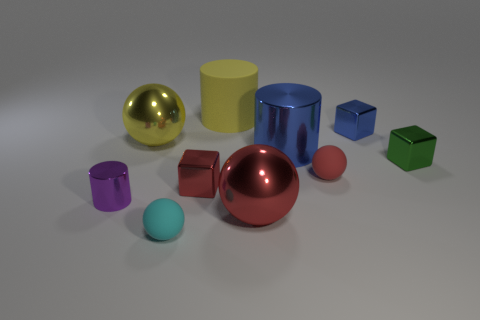Is the number of purple balls less than the number of red blocks?
Your answer should be very brief. Yes. How many cyan things are the same shape as the big yellow shiny object?
Offer a terse response. 1. What color is the rubber sphere that is the same size as the cyan rubber thing?
Offer a terse response. Red. Is the number of tiny red matte things that are to the left of the small purple metallic cylinder the same as the number of blue metal things left of the red rubber ball?
Ensure brevity in your answer.  No. Are there any green metal objects that have the same size as the purple cylinder?
Give a very brief answer. Yes. What is the size of the red matte thing?
Keep it short and to the point. Small. Are there an equal number of big balls that are behind the yellow metallic sphere and blue metal things?
Ensure brevity in your answer.  No. What number of other things are the same color as the tiny cylinder?
Provide a succinct answer. 0. The big metallic object that is to the left of the big blue cylinder and behind the tiny metal cylinder is what color?
Your response must be concise. Yellow. There is a ball to the right of the metal cylinder right of the ball behind the tiny red matte ball; what size is it?
Make the answer very short. Small. 